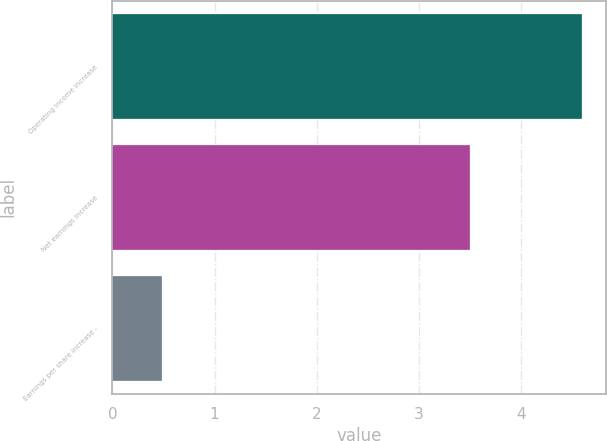Convert chart to OTSL. <chart><loc_0><loc_0><loc_500><loc_500><bar_chart><fcel>Operating income increase<fcel>Net earnings increase<fcel>Earnings per share increase -<nl><fcel>4.6<fcel>3.5<fcel>0.49<nl></chart> 